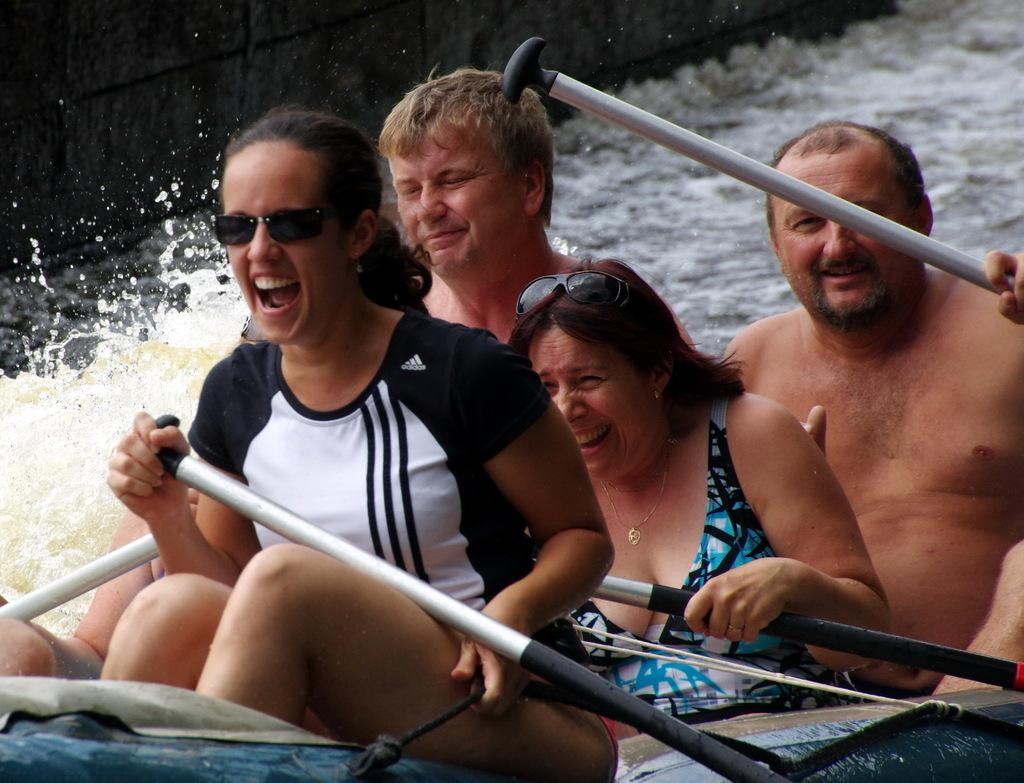How many people are in the image? There are four people in the image. Can you describe the clothing worn by the individuals in the image? All four individuals are wearing swimsuits. What activity are the people in the image engaged in? They are rafting in a canal. What type of yarn is being used to tie the raft together in the image? There is no yarn present in the image; the raft appears to be held together by other means. Can you tell me where the parcel is located in the image? There is no parcel present in the image. 